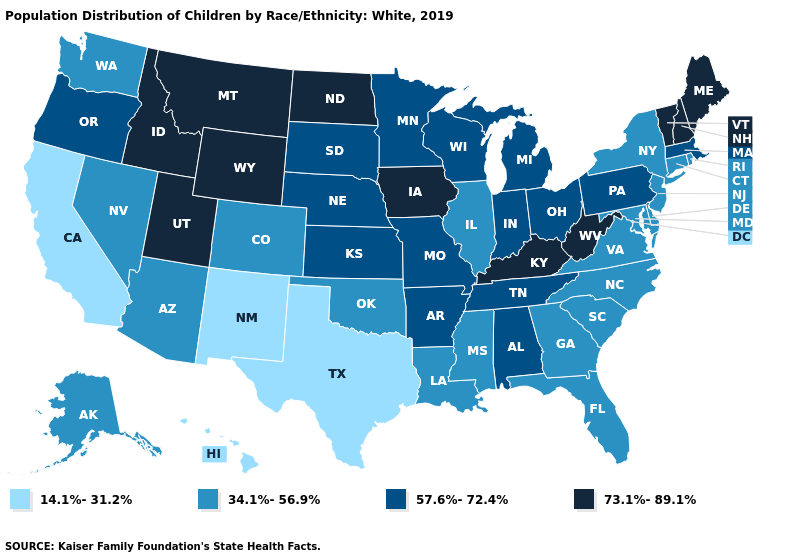What is the value of Connecticut?
Short answer required. 34.1%-56.9%. Does Illinois have the lowest value in the MidWest?
Keep it brief. Yes. Name the states that have a value in the range 34.1%-56.9%?
Answer briefly. Alaska, Arizona, Colorado, Connecticut, Delaware, Florida, Georgia, Illinois, Louisiana, Maryland, Mississippi, Nevada, New Jersey, New York, North Carolina, Oklahoma, Rhode Island, South Carolina, Virginia, Washington. What is the value of Iowa?
Concise answer only. 73.1%-89.1%. What is the value of Utah?
Short answer required. 73.1%-89.1%. Name the states that have a value in the range 57.6%-72.4%?
Be succinct. Alabama, Arkansas, Indiana, Kansas, Massachusetts, Michigan, Minnesota, Missouri, Nebraska, Ohio, Oregon, Pennsylvania, South Dakota, Tennessee, Wisconsin. Name the states that have a value in the range 73.1%-89.1%?
Give a very brief answer. Idaho, Iowa, Kentucky, Maine, Montana, New Hampshire, North Dakota, Utah, Vermont, West Virginia, Wyoming. What is the value of New York?
Concise answer only. 34.1%-56.9%. Among the states that border Pennsylvania , does New York have the lowest value?
Quick response, please. Yes. Does Utah have the highest value in the USA?
Short answer required. Yes. What is the highest value in the USA?
Write a very short answer. 73.1%-89.1%. Among the states that border North Dakota , which have the lowest value?
Concise answer only. Minnesota, South Dakota. Which states have the lowest value in the South?
Be succinct. Texas. What is the value of Rhode Island?
Quick response, please. 34.1%-56.9%. 